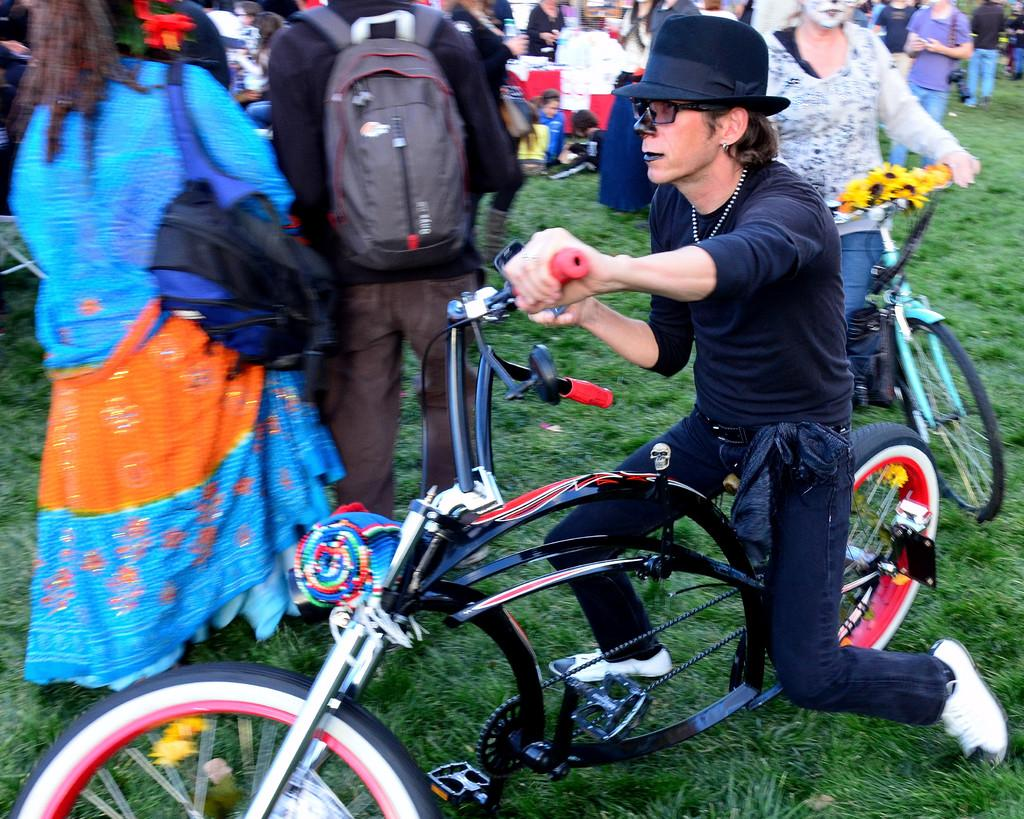How many people are in the image? There are two persons in the image. What are the two persons doing in the image? The two persons are on a cycle. Can you describe the background of the image? There are people in the background of the image, and they are on the grass. What type of grape is being used to paint the canvas in the image? There is no grape or canvas present in the image; it features two persons on a cycle with people in the background on the grass. 